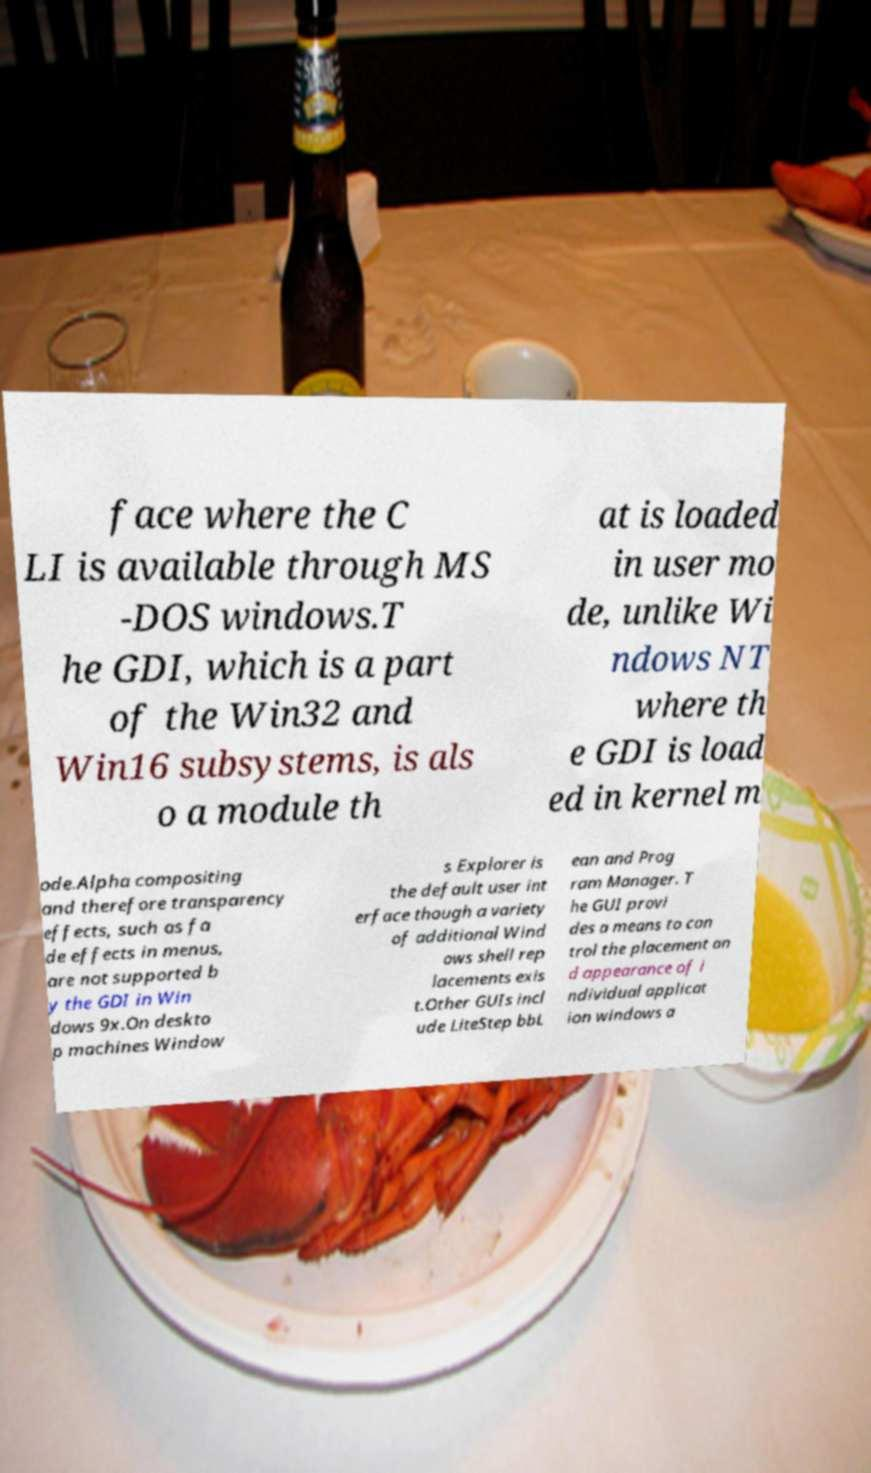Can you accurately transcribe the text from the provided image for me? face where the C LI is available through MS -DOS windows.T he GDI, which is a part of the Win32 and Win16 subsystems, is als o a module th at is loaded in user mo de, unlike Wi ndows NT where th e GDI is load ed in kernel m ode.Alpha compositing and therefore transparency effects, such as fa de effects in menus, are not supported b y the GDI in Win dows 9x.On deskto p machines Window s Explorer is the default user int erface though a variety of additional Wind ows shell rep lacements exis t.Other GUIs incl ude LiteStep bbL ean and Prog ram Manager. T he GUI provi des a means to con trol the placement an d appearance of i ndividual applicat ion windows a 